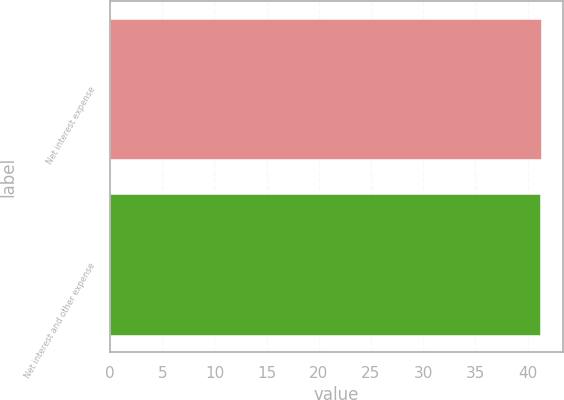Convert chart. <chart><loc_0><loc_0><loc_500><loc_500><bar_chart><fcel>Net interest expense<fcel>Net interest and other expense<nl><fcel>41.3<fcel>41.2<nl></chart> 